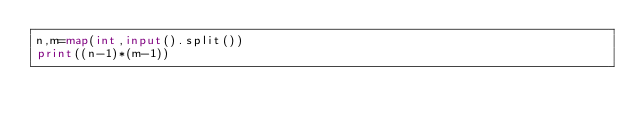Convert code to text. <code><loc_0><loc_0><loc_500><loc_500><_Python_>n,m=map(int,input().split())
print((n-1)*(m-1))</code> 